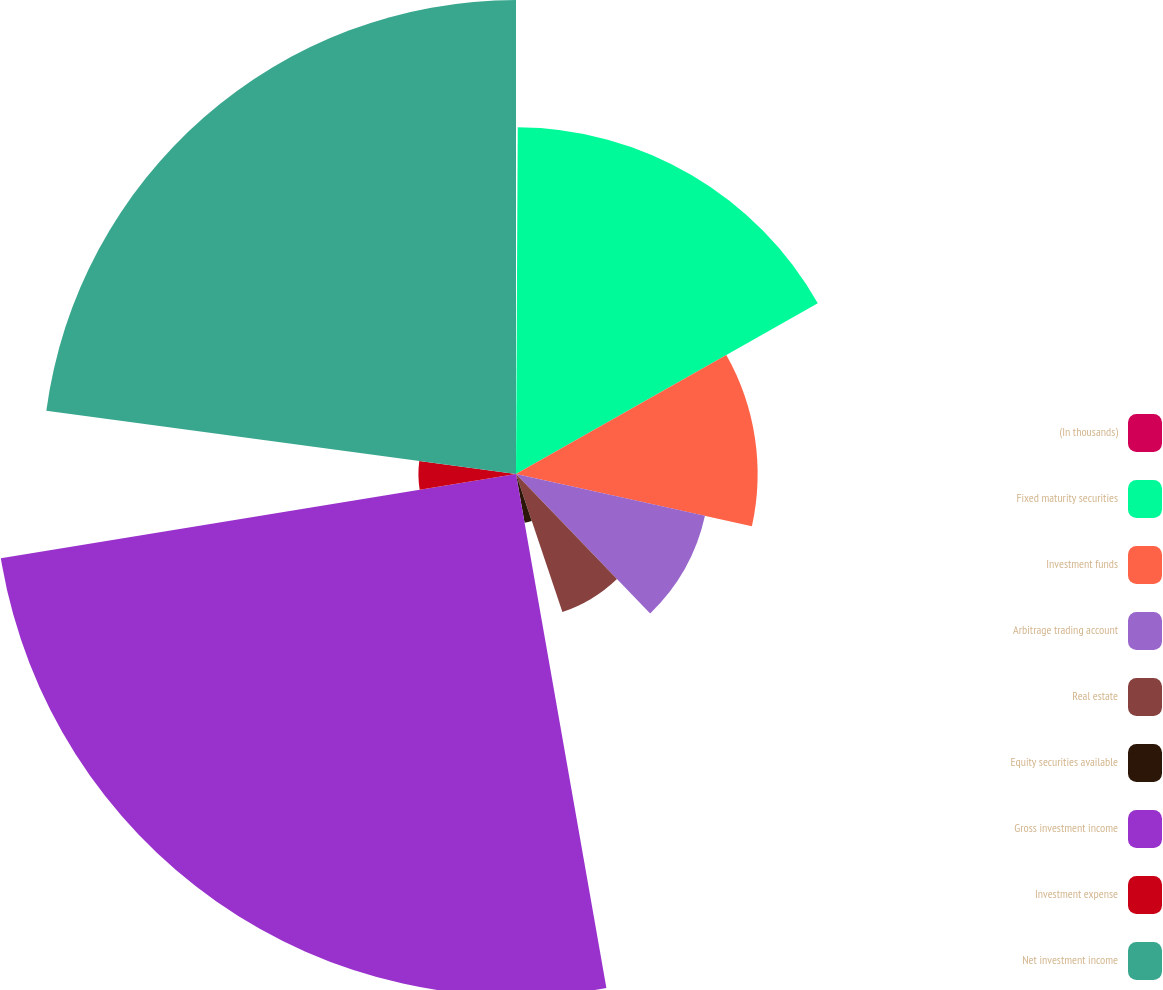<chart> <loc_0><loc_0><loc_500><loc_500><pie_chart><fcel>(In thousands)<fcel>Fixed maturity securities<fcel>Investment funds<fcel>Arbitrage trading account<fcel>Real estate<fcel>Equity securities available<fcel>Gross investment income<fcel>Investment expense<fcel>Net investment income<nl><fcel>0.08%<fcel>16.73%<fcel>11.66%<fcel>9.34%<fcel>7.03%<fcel>2.39%<fcel>25.19%<fcel>4.71%<fcel>22.87%<nl></chart> 